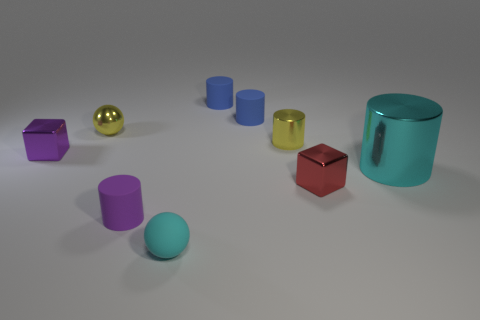What number of other small metallic objects are the same shape as the small red metallic object? 1 